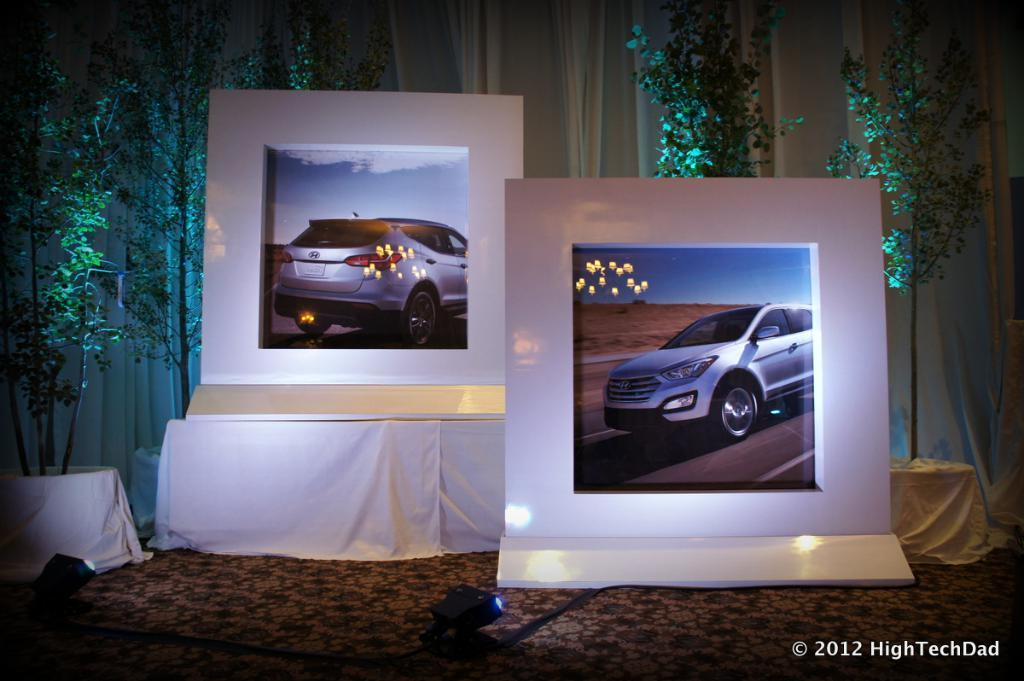What objects can be seen in the image? There are boards in the image. What can be seen in the background of the image? There are plants and curtains in the background of the image. What type of comb is used by the slave in the image? There is no slave or comb present in the image. 